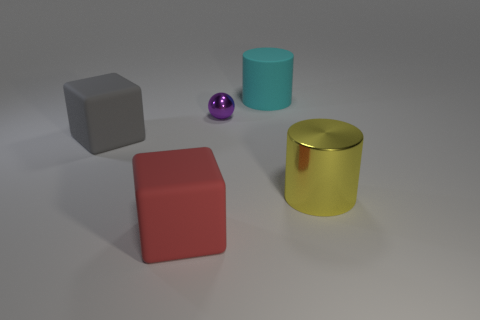Add 4 blue rubber spheres. How many objects exist? 9 Add 5 tiny metal things. How many tiny metal things exist? 6 Subtract 0 brown cylinders. How many objects are left? 5 Subtract all cylinders. How many objects are left? 3 Subtract 1 balls. How many balls are left? 0 Subtract all brown balls. Subtract all gray cubes. How many balls are left? 1 Subtract all gray blocks. How many cyan spheres are left? 0 Subtract all small purple metallic cubes. Subtract all big blocks. How many objects are left? 3 Add 1 big yellow cylinders. How many big yellow cylinders are left? 2 